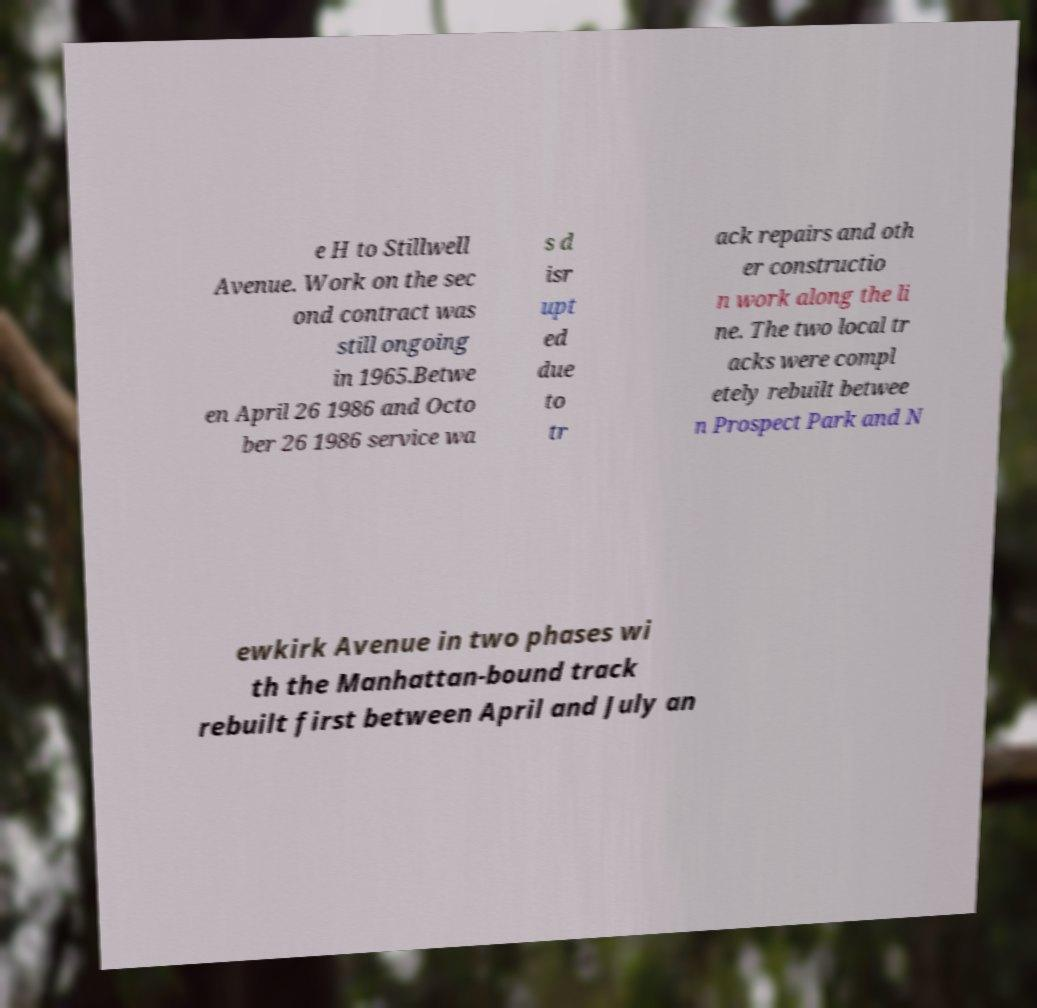Can you read and provide the text displayed in the image?This photo seems to have some interesting text. Can you extract and type it out for me? e H to Stillwell Avenue. Work on the sec ond contract was still ongoing in 1965.Betwe en April 26 1986 and Octo ber 26 1986 service wa s d isr upt ed due to tr ack repairs and oth er constructio n work along the li ne. The two local tr acks were compl etely rebuilt betwee n Prospect Park and N ewkirk Avenue in two phases wi th the Manhattan-bound track rebuilt first between April and July an 